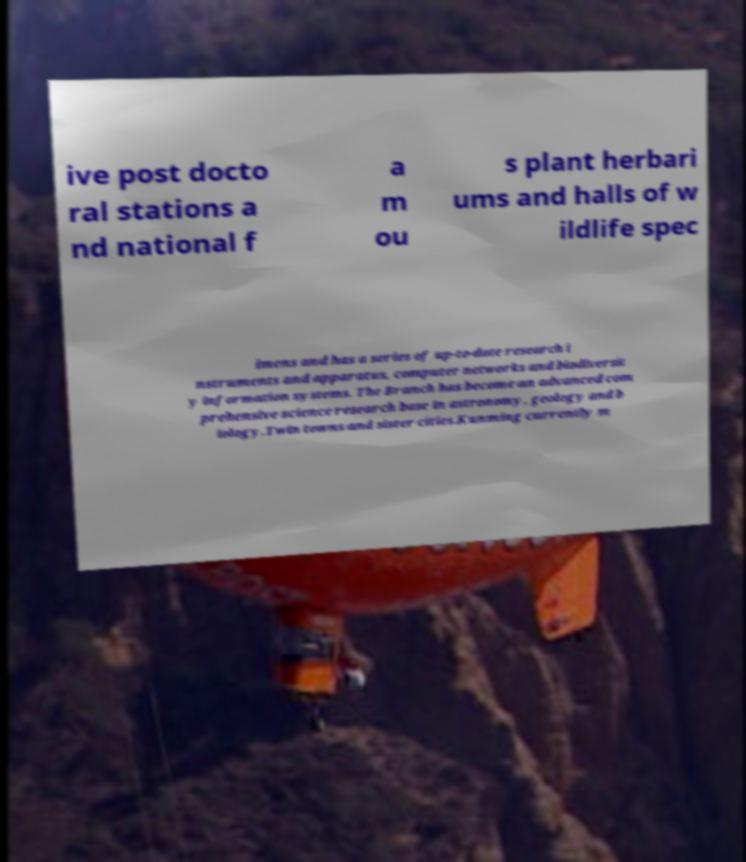There's text embedded in this image that I need extracted. Can you transcribe it verbatim? ive post docto ral stations a nd national f a m ou s plant herbari ums and halls of w ildlife spec imens and has a series of up-to-date research i nstruments and apparatus, computer networks and biodiversit y information systems. The Branch has become an advanced com prehensive science research base in astronomy, geology and b iology.Twin towns and sister cities.Kunming currently m 